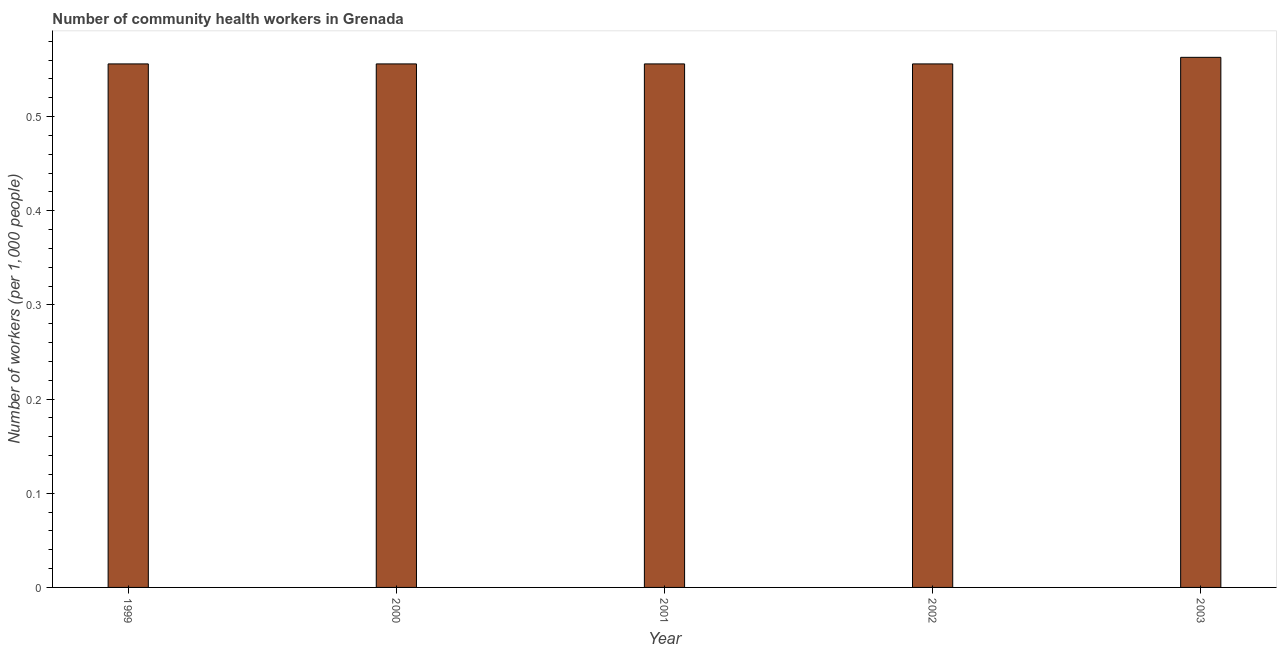Does the graph contain any zero values?
Your response must be concise. No. What is the title of the graph?
Ensure brevity in your answer.  Number of community health workers in Grenada. What is the label or title of the X-axis?
Offer a very short reply. Year. What is the label or title of the Y-axis?
Offer a terse response. Number of workers (per 1,0 people). What is the number of community health workers in 2002?
Provide a short and direct response. 0.56. Across all years, what is the maximum number of community health workers?
Give a very brief answer. 0.56. Across all years, what is the minimum number of community health workers?
Keep it short and to the point. 0.56. In which year was the number of community health workers maximum?
Make the answer very short. 2003. In which year was the number of community health workers minimum?
Your answer should be compact. 1999. What is the sum of the number of community health workers?
Give a very brief answer. 2.79. What is the difference between the number of community health workers in 1999 and 2000?
Provide a short and direct response. 0. What is the average number of community health workers per year?
Make the answer very short. 0.56. What is the median number of community health workers?
Provide a succinct answer. 0.56. In how many years, is the number of community health workers greater than 0.48 ?
Your response must be concise. 5. Do a majority of the years between 2002 and 2001 (inclusive) have number of community health workers greater than 0.48 ?
Your answer should be very brief. No. What is the ratio of the number of community health workers in 2000 to that in 2001?
Provide a short and direct response. 1. Is the number of community health workers in 2000 less than that in 2001?
Your answer should be very brief. No. What is the difference between the highest and the second highest number of community health workers?
Ensure brevity in your answer.  0.01. Is the sum of the number of community health workers in 2000 and 2002 greater than the maximum number of community health workers across all years?
Your answer should be very brief. Yes. What is the difference between the highest and the lowest number of community health workers?
Your response must be concise. 0.01. In how many years, is the number of community health workers greater than the average number of community health workers taken over all years?
Provide a short and direct response. 1. How many bars are there?
Offer a terse response. 5. How many years are there in the graph?
Provide a short and direct response. 5. What is the Number of workers (per 1,000 people) of 1999?
Your answer should be compact. 0.56. What is the Number of workers (per 1,000 people) of 2000?
Provide a succinct answer. 0.56. What is the Number of workers (per 1,000 people) of 2001?
Make the answer very short. 0.56. What is the Number of workers (per 1,000 people) of 2002?
Offer a terse response. 0.56. What is the Number of workers (per 1,000 people) in 2003?
Make the answer very short. 0.56. What is the difference between the Number of workers (per 1,000 people) in 1999 and 2000?
Your response must be concise. 0. What is the difference between the Number of workers (per 1,000 people) in 1999 and 2002?
Give a very brief answer. 0. What is the difference between the Number of workers (per 1,000 people) in 1999 and 2003?
Your response must be concise. -0.01. What is the difference between the Number of workers (per 1,000 people) in 2000 and 2001?
Keep it short and to the point. 0. What is the difference between the Number of workers (per 1,000 people) in 2000 and 2002?
Your answer should be compact. 0. What is the difference between the Number of workers (per 1,000 people) in 2000 and 2003?
Your answer should be very brief. -0.01. What is the difference between the Number of workers (per 1,000 people) in 2001 and 2003?
Your response must be concise. -0.01. What is the difference between the Number of workers (per 1,000 people) in 2002 and 2003?
Offer a very short reply. -0.01. What is the ratio of the Number of workers (per 1,000 people) in 1999 to that in 2002?
Make the answer very short. 1. What is the ratio of the Number of workers (per 1,000 people) in 2000 to that in 2003?
Keep it short and to the point. 0.99. 